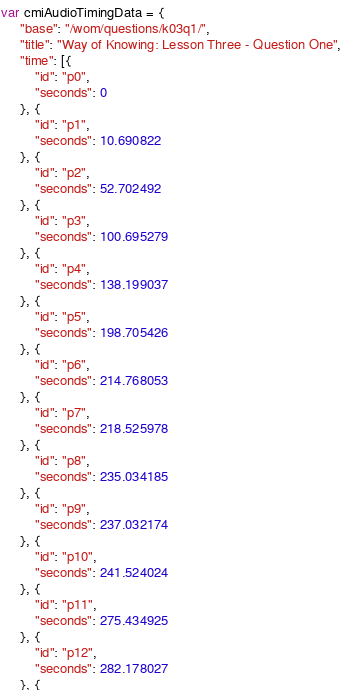Convert code to text. <code><loc_0><loc_0><loc_500><loc_500><_JavaScript_>var cmiAudioTimingData = {
     "base": "/wom/questions/k03q1/",
     "title": "Way of Knowing: Lesson Three - Question One",
     "time": [{
         "id": "p0",
         "seconds": 0
     }, {
         "id": "p1",
         "seconds": 10.690822
     }, {
         "id": "p2",
         "seconds": 52.702492
     }, {
         "id": "p3",
         "seconds": 100.695279
     }, {
         "id": "p4",
         "seconds": 138.199037
     }, {
         "id": "p5",
         "seconds": 198.705426
     }, {
         "id": "p6",
         "seconds": 214.768053
     }, {
         "id": "p7",
         "seconds": 218.525978
     }, {
         "id": "p8",
         "seconds": 235.034185
     }, {
         "id": "p9",
         "seconds": 237.032174
     }, {
         "id": "p10",
         "seconds": 241.524024
     }, {
         "id": "p11",
         "seconds": 275.434925
     }, {
         "id": "p12",
         "seconds": 282.178027
     }, {</code> 